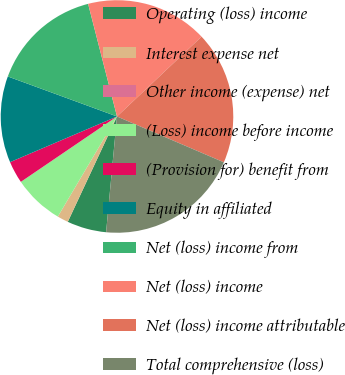Convert chart to OTSL. <chart><loc_0><loc_0><loc_500><loc_500><pie_chart><fcel>Operating (loss) income<fcel>Interest expense net<fcel>Other income (expense) net<fcel>(Loss) income before income<fcel>(Provision for) benefit from<fcel>Equity in affiliated<fcel>Net (loss) income from<fcel>Net (loss) income<fcel>Net (loss) income attributable<fcel>Total comprehensive (loss)<nl><fcel>5.46%<fcel>1.54%<fcel>0.0%<fcel>7.0%<fcel>3.08%<fcel>12.01%<fcel>15.41%<fcel>16.95%<fcel>18.49%<fcel>20.04%<nl></chart> 